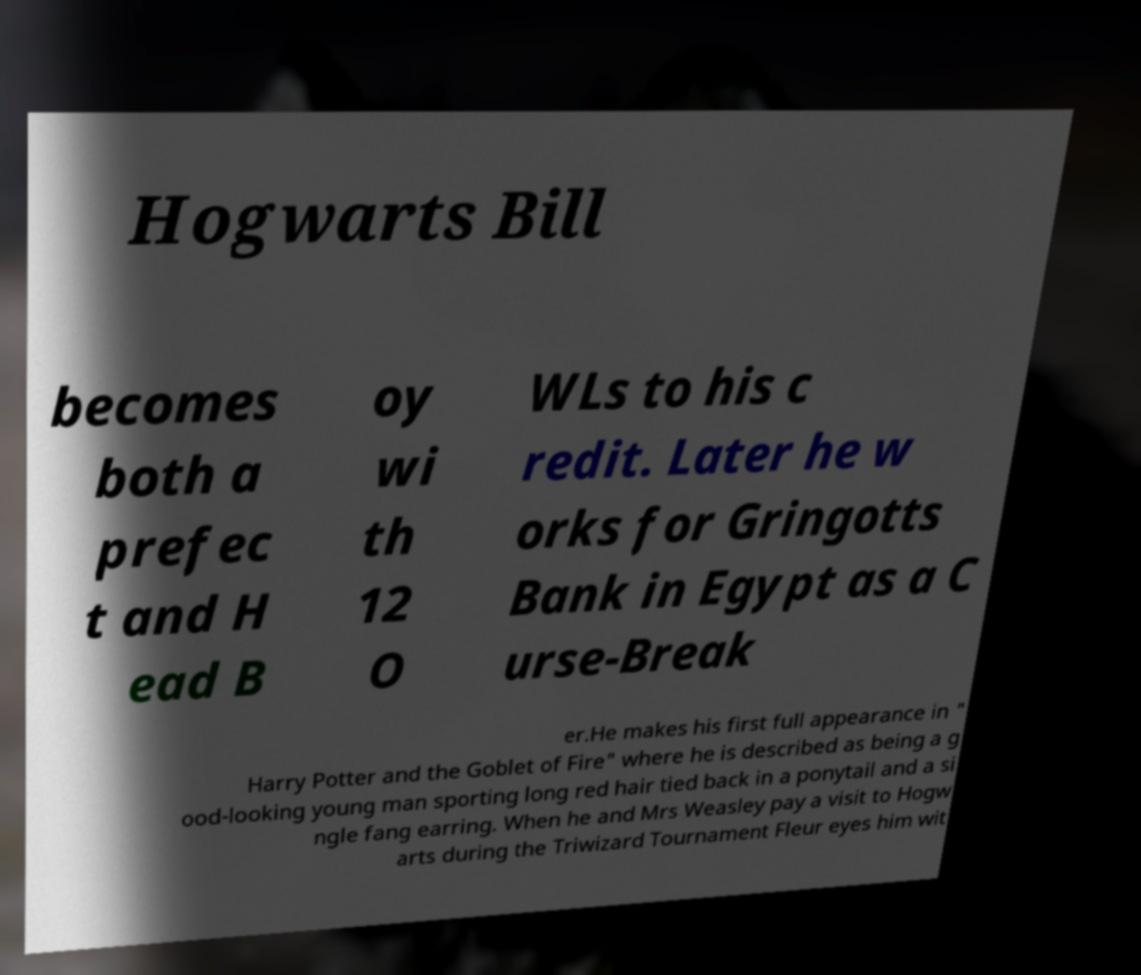For documentation purposes, I need the text within this image transcribed. Could you provide that? Hogwarts Bill becomes both a prefec t and H ead B oy wi th 12 O WLs to his c redit. Later he w orks for Gringotts Bank in Egypt as a C urse-Break er.He makes his first full appearance in " Harry Potter and the Goblet of Fire" where he is described as being a g ood-looking young man sporting long red hair tied back in a ponytail and a si ngle fang earring. When he and Mrs Weasley pay a visit to Hogw arts during the Triwizard Tournament Fleur eyes him wit 